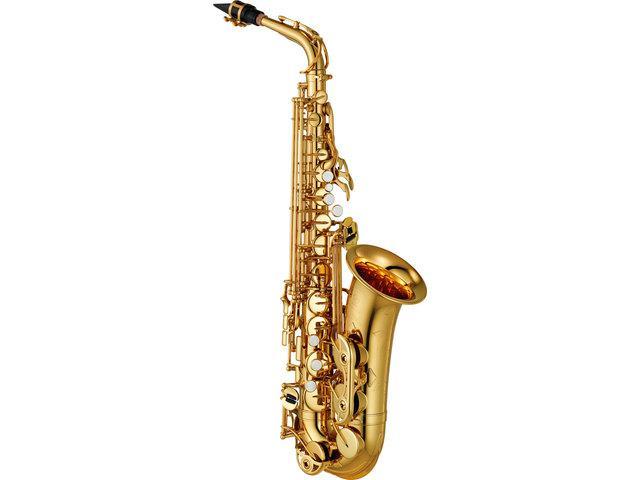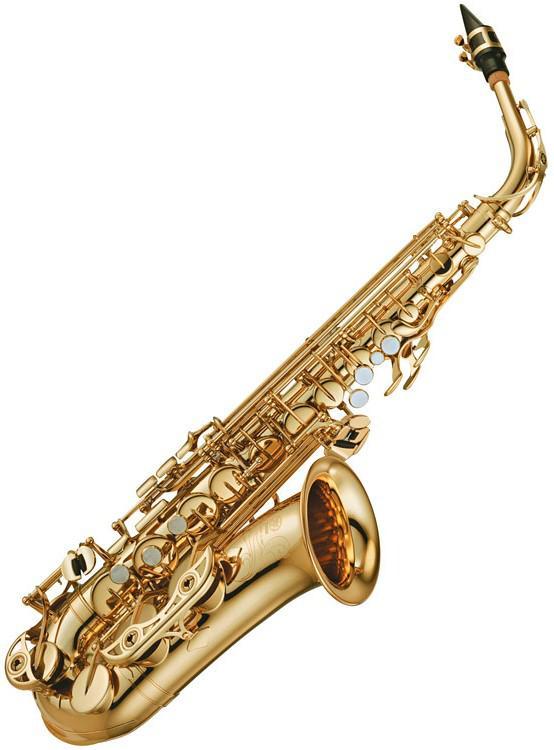The first image is the image on the left, the second image is the image on the right. Evaluate the accuracy of this statement regarding the images: "There is a saxophone in each image.". Is it true? Answer yes or no. Yes. The first image is the image on the left, the second image is the image on the right. Assess this claim about the two images: "One image shows only a straight wind instrument, which is brass colored and does not have an upturned bell.". Correct or not? Answer yes or no. No. 